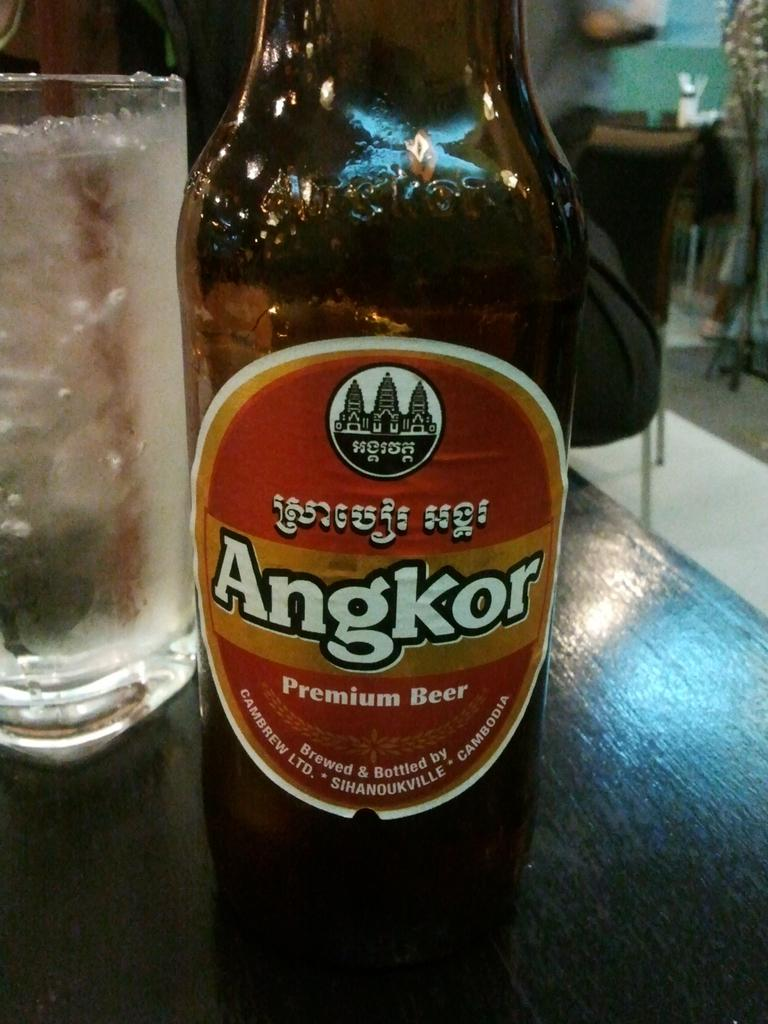<image>
Present a compact description of the photo's key features. An Angkor Premium beer bottle with a brown and gold label. 